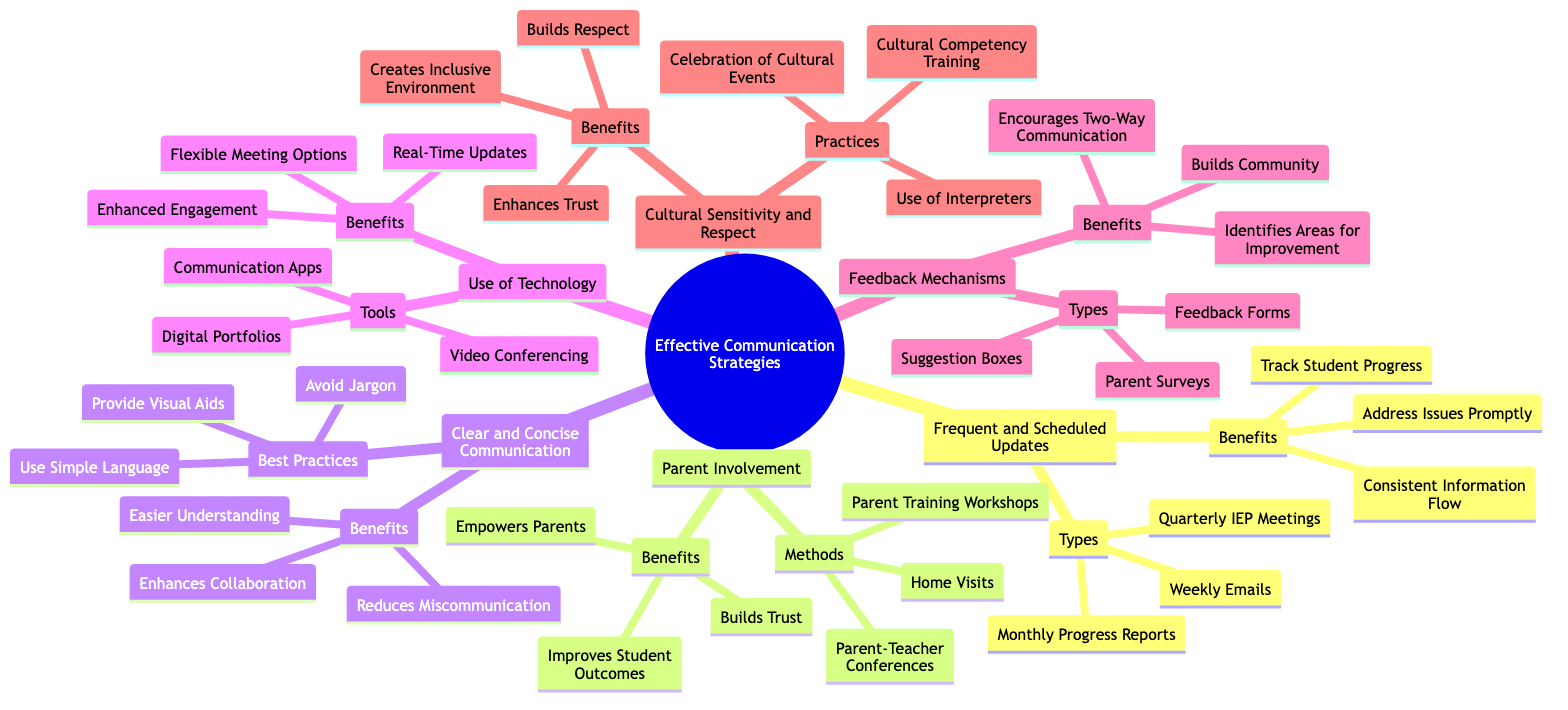What are the three types of frequent and scheduled updates? The node "Frequent and Scheduled Updates" connects to a subnode labeled "Types," which lists "Weekly Emails," "Monthly Progress Reports," and "Quarterly IEP Meetings."
Answer: Weekly Emails, Monthly Progress Reports, Quarterly IEP Meetings How many benefits are associated with clear and concise communication? The "Clear and Concise Communication" node links to its subnode labeled "Benefits," which has three entries: "Easier Understanding," "Reduces Miscommunication," and "Enhances Collaboration."
Answer: 3 What is one method for parent involvement? The "Parent Involvement" node contains a subnode labeled "Methods" with three options, including "Parent-Teacher Conferences," which represents just one method of involvement.
Answer: Parent-Teacher Conferences Which communication tool allows for real-time updates? Under the "Use of Technology" node, the subnode labeled "Benefits" lists items, and "Real-Time Updates" directly corresponds to the tools discussed, indicating its significance.
Answer: Real-Time Updates What is the total number of feedback mechanism types listed? The "Feedback Mechanisms" node leads to a subnode labeled "Types," which includes "Parent Surveys," "Feedback Forms," and "Suggestion Boxes," totaling three types.
Answer: 3 How does cultural sensitivity enhance communication? The node "Cultural Sensitivity and Respect" connects to a subnode titled "Benefits," which includes "Enhances Trust," showing how respect and understanding lead to better communication outcomes.
Answer: Enhances Trust What are two practices for cultural sensitivity? The "Cultural Sensitivity and Respect" node has a subnode labeled "Practices," which includes "Cultural Competency Training" and "Use of Interpreters," providing two specific practices.
Answer: Cultural Competency Training, Use of Interpreters What benefit does parent training workshops provide? The "Parent Involvement" node lists benefits under "Benefits," with "Empowers Parents" directly linked to the method of "Parent Training Workshops."
Answer: Empowers Parents 